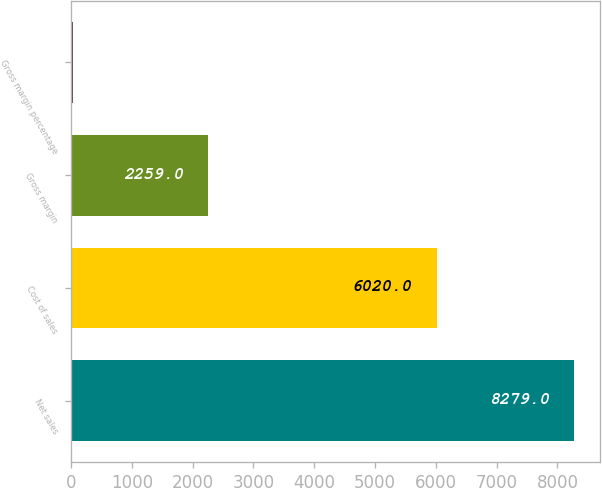Convert chart. <chart><loc_0><loc_0><loc_500><loc_500><bar_chart><fcel>Net sales<fcel>Cost of sales<fcel>Gross margin<fcel>Gross margin percentage<nl><fcel>8279<fcel>6020<fcel>2259<fcel>27.3<nl></chart> 